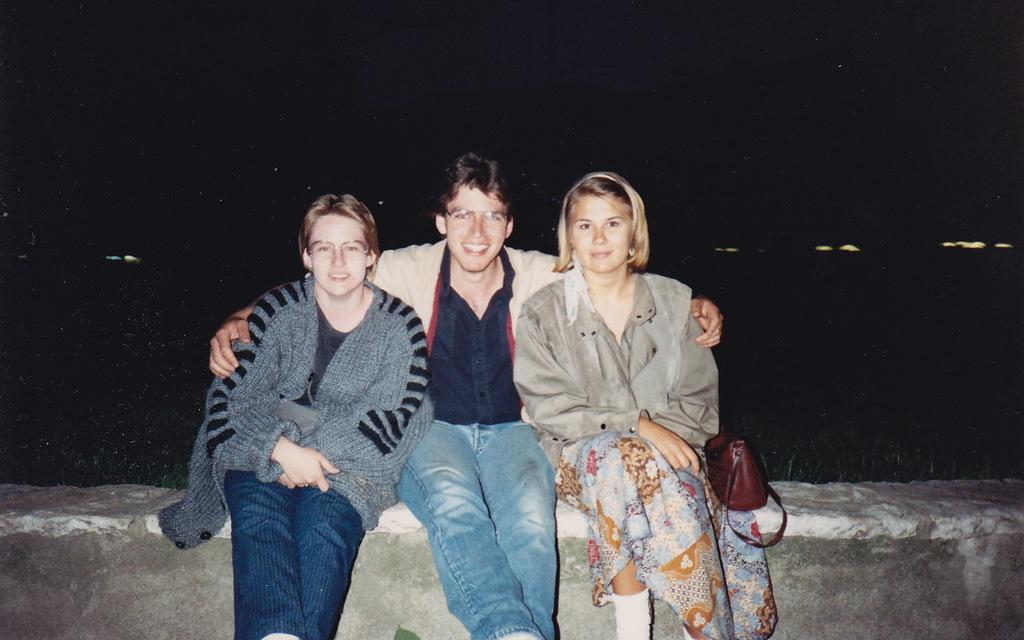What are the people in the image doing? The persons in the image are sitting on a platform. What object can be seen on the platform besides the people? There is a handbag on the platform. How would you describe the overall lighting in the image? The background of the image is dark, but there are lights visible in the background. What word is written on the list in the image? There is no list or word present in the image. What type of picture is hanging on the wall in the image? There is no picture hanging on the wall in the image. 